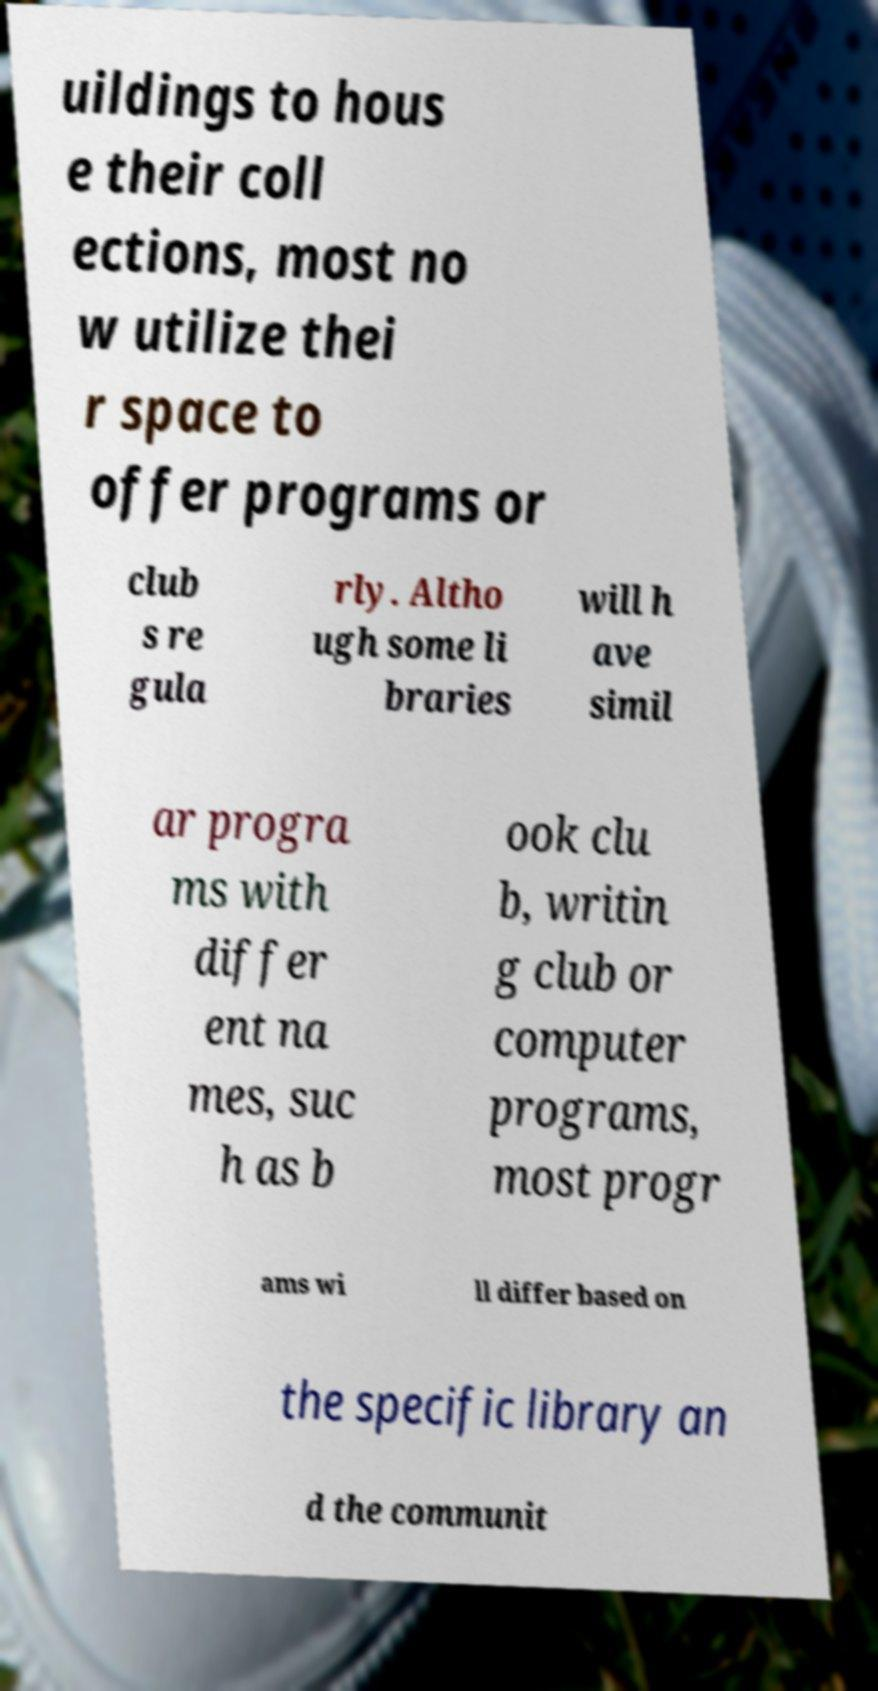What messages or text are displayed in this image? I need them in a readable, typed format. uildings to hous e their coll ections, most no w utilize thei r space to offer programs or club s re gula rly. Altho ugh some li braries will h ave simil ar progra ms with differ ent na mes, suc h as b ook clu b, writin g club or computer programs, most progr ams wi ll differ based on the specific library an d the communit 